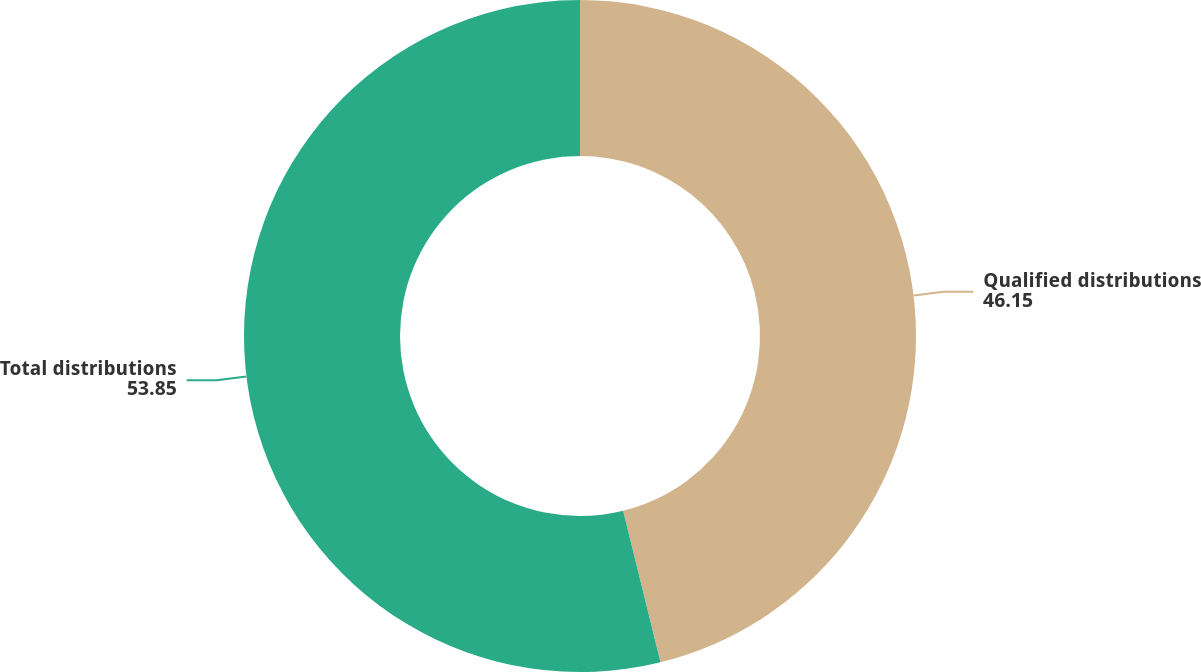Convert chart. <chart><loc_0><loc_0><loc_500><loc_500><pie_chart><fcel>Qualified distributions<fcel>Total distributions<nl><fcel>46.15%<fcel>53.85%<nl></chart> 